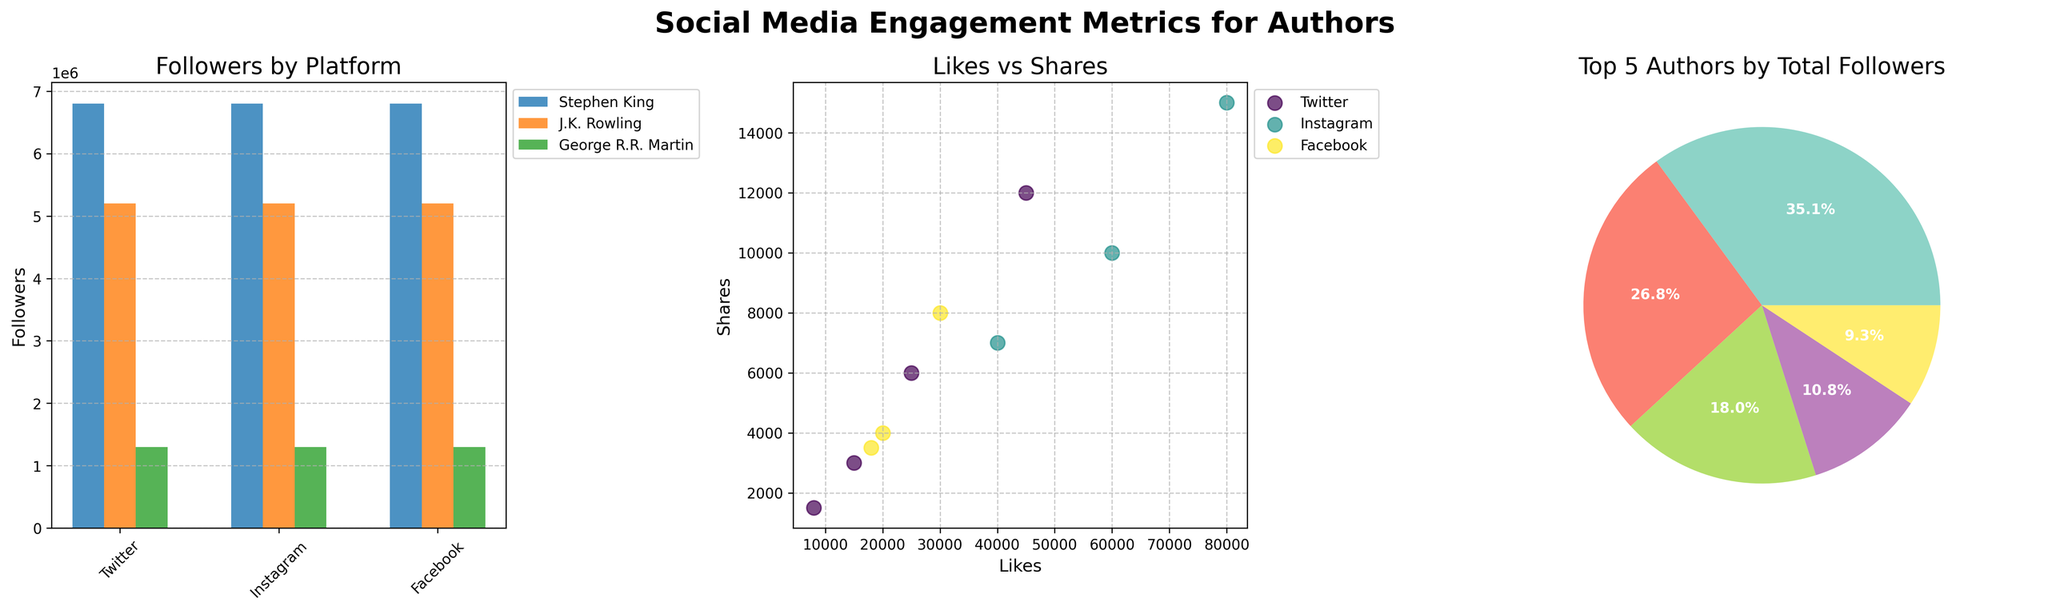How many platforms are represented in the bar plot for Followers? There are three bars in the bar plot for Followers, each representing platforms labelled as Twitter, Instagram, and Facebook.
Answer: 3 Which author has the highest number of Likes on Instagram according to the scatter plot? By examining the scatter plot's markers, J.K. Rowling's data point on Instagram has the highest number of Likes, indicated by its higher position on the x-axis compared to other Instagram data points.
Answer: J.K. Rowling What is the total percentage of Followers for the top author in the pie chart? The pie chart shows Stephen King as the top author with a specific percentage indicated. Based on the pie chart visualization, Stephen King's segment is marked with the highest share.
Answer: Stephen King Compare the number of Shares for the three authors shown in the bar plot for Followers on Twitter. Who has the least? From the bar plot, under the Twitter platform, the authors shown are Stephen King, Margaret Atwood, and Gillian Flynn. By comparing their Shares, Gillian Flynn has the lowest number.
Answer: Gillian Flynn How do the Likes compare between Twitter and Facebook in the scatter plot? In the scatter plot, the markers for Twitter Likes are generally positioned higher on the x-axis compared to those for Facebook, indicating that Twitter generally has more Likes than Facebook.
Answer: Twitter has more Likes Which author contributes the most to the total Followers in the pie chart? The pie chart's largest segment represents Stephen King, indicating that Stephen King contributes the most to the total Followers.
Answer: Stephen King In the scatter plot, what can you infer about the relationship between Likes and Shares on Facebook? Observing the scatter plot, the Facebook markers are clustered closely together, implying a positive correlation, where more Likes generally result in more Shares.
Answer: Positive correlation Who has more Followers on Instagram, Neil Gaiman or Dan Brown? By looking at the bar plot for Followers under Instagram, the bar for Neil Gaiman is taller than that for Dan Brown, denoting that Neil Gaiman has more Followers.
Answer: Neil Gaiman Which platform has the highest overall Followers for the top three authors in the bar plot? Summing up the bars for Stephen King, J.K. Rowling, and George R.R. Martin across the platforms, Instagram has the highest cumulative Followers for these three authors.
Answer: Instagram By viewing all three subplots together, which element stands out for author engagement metrics? Stephen King's segment is prominent across all three subplots—having the highest bar in Followers on Twitter, being substantial in the scatter plot for Shares and Likes, and dominating the pie chart for total Followers, making him a standout in engagement metrics.
Answer: Stephen King 